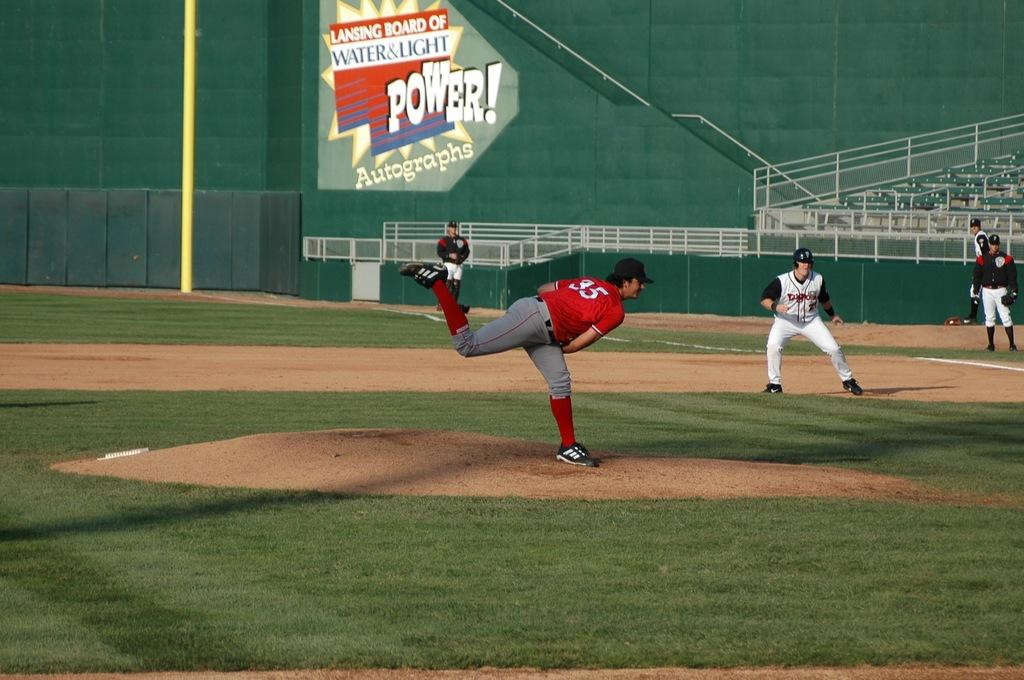<image>
Give a short and clear explanation of the subsequent image. Player number 35 in red throws a pitch to a batter. 